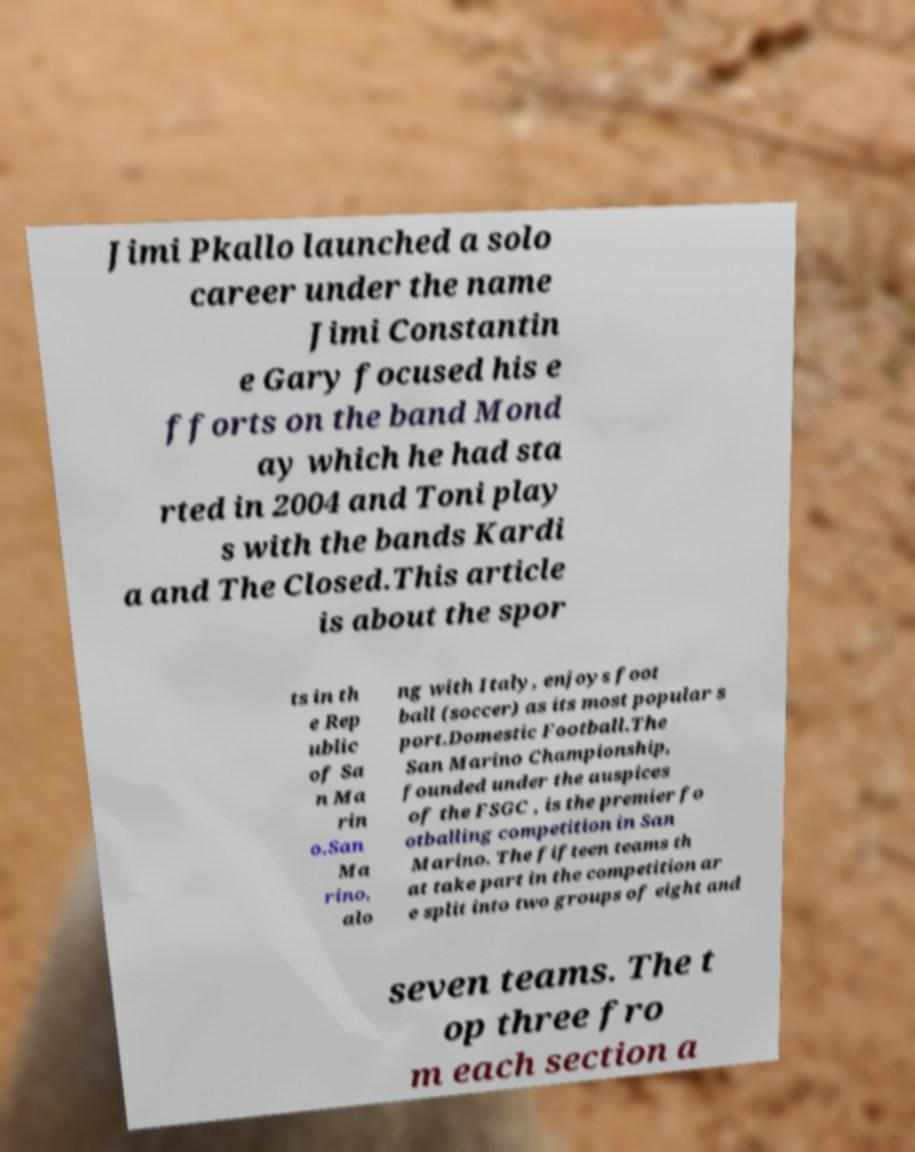Can you accurately transcribe the text from the provided image for me? Jimi Pkallo launched a solo career under the name Jimi Constantin e Gary focused his e fforts on the band Mond ay which he had sta rted in 2004 and Toni play s with the bands Kardi a and The Closed.This article is about the spor ts in th e Rep ublic of Sa n Ma rin o.San Ma rino, alo ng with Italy, enjoys foot ball (soccer) as its most popular s port.Domestic Football.The San Marino Championship, founded under the auspices of the FSGC , is the premier fo otballing competition in San Marino. The fifteen teams th at take part in the competition ar e split into two groups of eight and seven teams. The t op three fro m each section a 